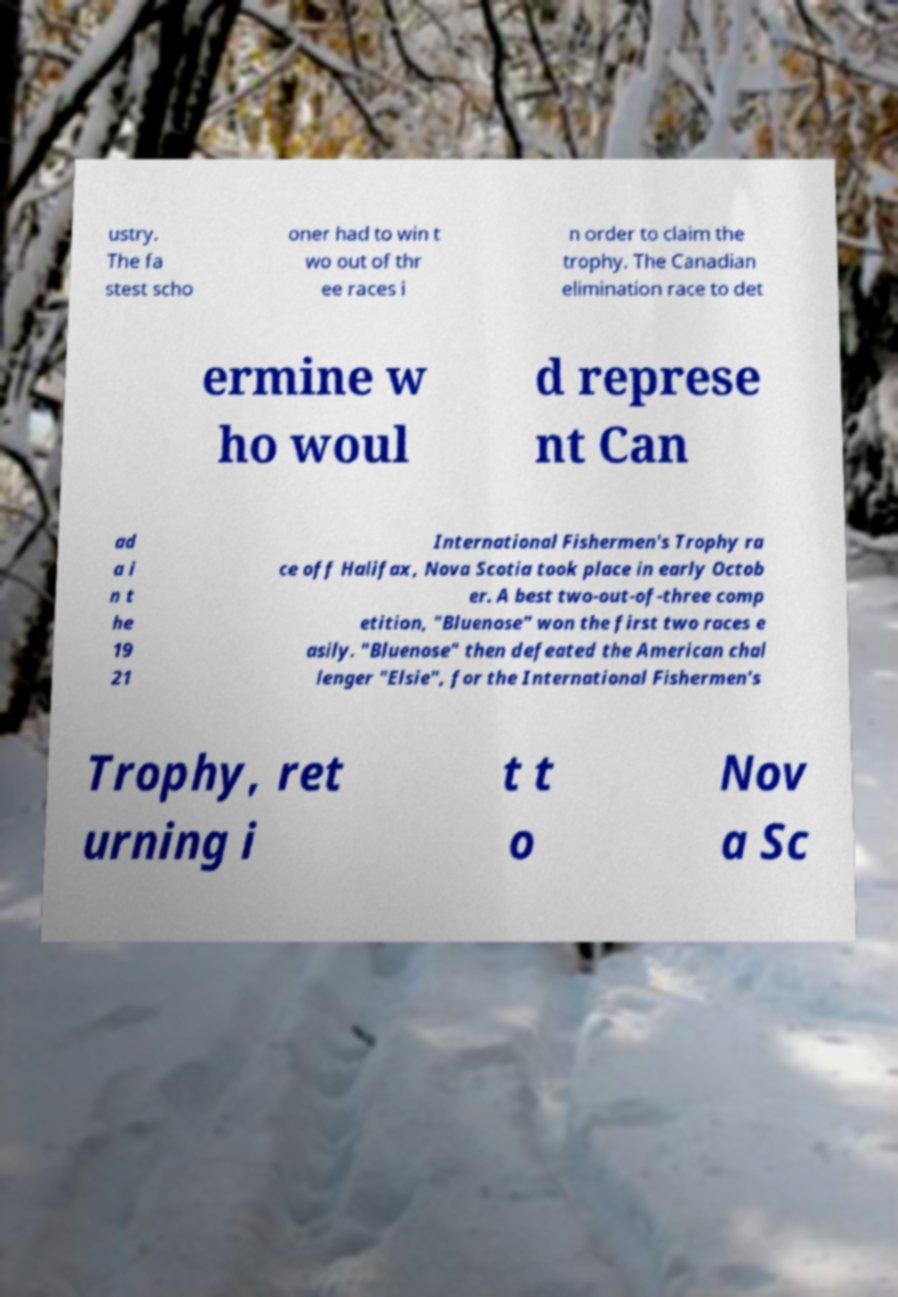Please read and relay the text visible in this image. What does it say? ustry. The fa stest scho oner had to win t wo out of thr ee races i n order to claim the trophy. The Canadian elimination race to det ermine w ho woul d represe nt Can ad a i n t he 19 21 International Fishermen's Trophy ra ce off Halifax, Nova Scotia took place in early Octob er. A best two-out-of-three comp etition, "Bluenose" won the first two races e asily. "Bluenose" then defeated the American chal lenger "Elsie", for the International Fishermen's Trophy, ret urning i t t o Nov a Sc 